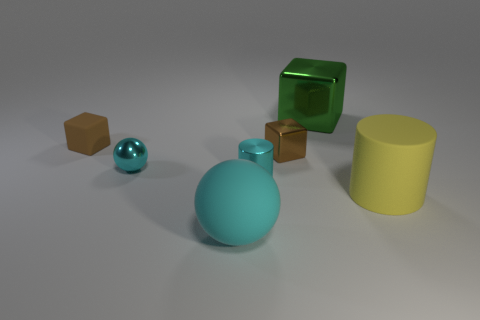Subtract all green cubes. How many cubes are left? 2 Subtract all rubber blocks. How many blocks are left? 2 Add 1 cyan balls. How many objects exist? 8 Subtract all blocks. How many objects are left? 4 Add 7 large metallic cubes. How many large metallic cubes are left? 8 Add 5 large cyan spheres. How many large cyan spheres exist? 6 Subtract 1 green blocks. How many objects are left? 6 Subtract 1 cylinders. How many cylinders are left? 1 Subtract all yellow cubes. Subtract all gray balls. How many cubes are left? 3 Subtract all brown cubes. How many purple cylinders are left? 0 